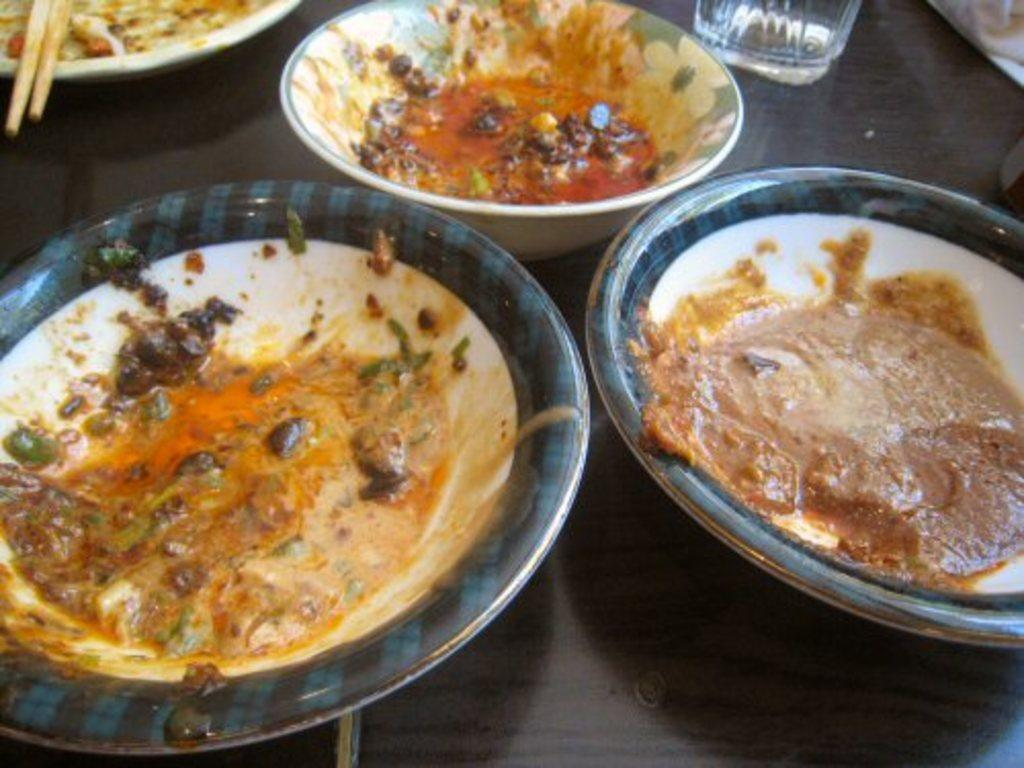What is in the image that can hold food? There is a bowl in the image that can hold food. What else can be used to hold food in the image? There are plates in the image that can also hold food. What can be used to drink in the image? There is a glass in the image that can be used to drink. What utensils are present in the image? There are chopsticks in the image. What is the main type of food visible in the image? There is food in the image. What surface is the food placed on in the image? The wooden surface is present in the image. Can you see any fairies flying around the food in the image? No, there are no fairies present in the image. What type of cloud is visible in the image? There are no clouds visible in the image, as it is focused on a table setting with food, utensils, and a wooden surface. 